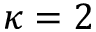<formula> <loc_0><loc_0><loc_500><loc_500>\kappa = 2</formula> 